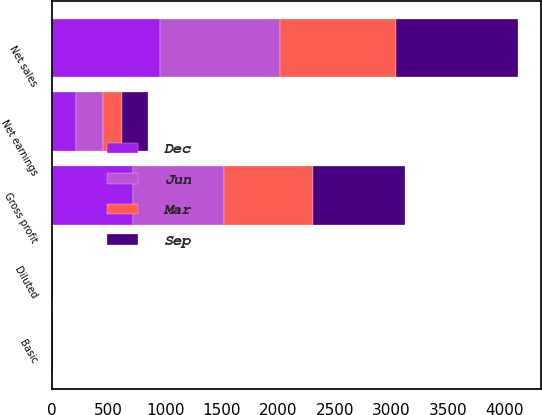Convert chart to OTSL. <chart><loc_0><loc_0><loc_500><loc_500><stacked_bar_chart><ecel><fcel>Net sales<fcel>Gross profit<fcel>Net earnings<fcel>Basic<fcel>Diluted<nl><fcel>Jun<fcel>1059.2<fcel>804.5<fcel>239.3<fcel>1.03<fcel>1.02<nl><fcel>Sep<fcel>1079.5<fcel>817.2<fcel>227.1<fcel>0.99<fcel>0.99<nl><fcel>Dec<fcel>952.2<fcel>715<fcel>214.7<fcel>0.96<fcel>0.95<nl><fcel>Mar<fcel>1030.2<fcel>787.1<fcel>167.5<fcel>0.75<fcel>0.75<nl></chart> 